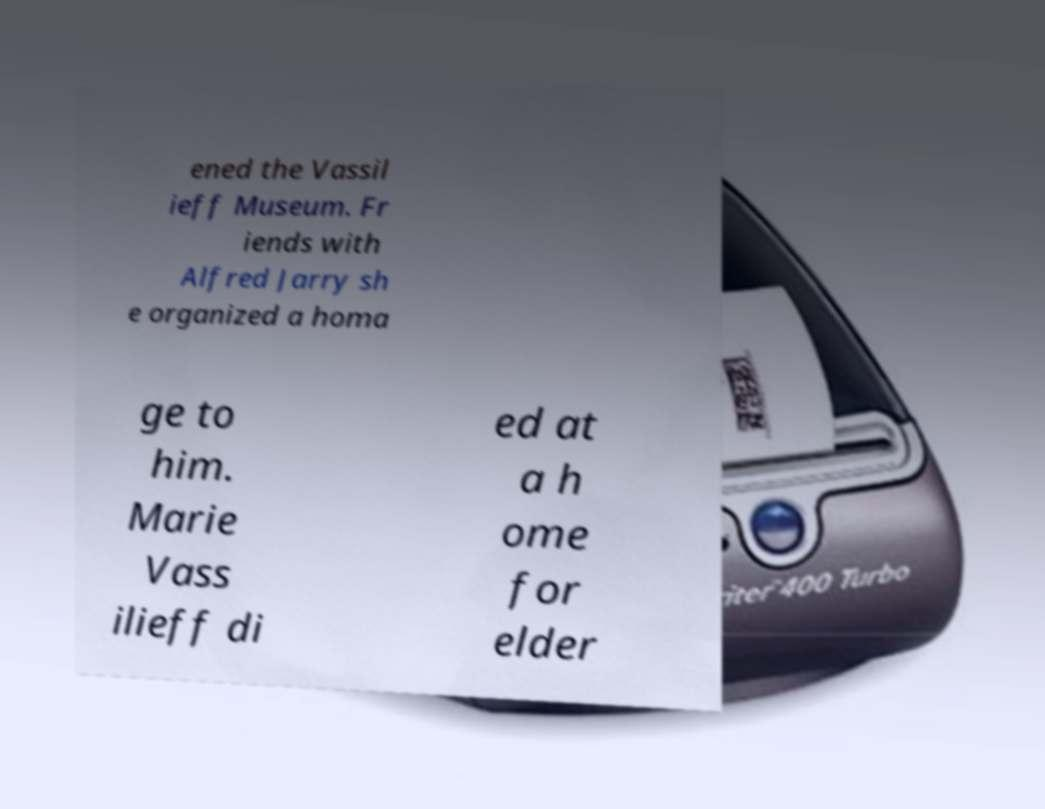Please read and relay the text visible in this image. What does it say? ened the Vassil ieff Museum. Fr iends with Alfred Jarry sh e organized a homa ge to him. Marie Vass ilieff di ed at a h ome for elder 